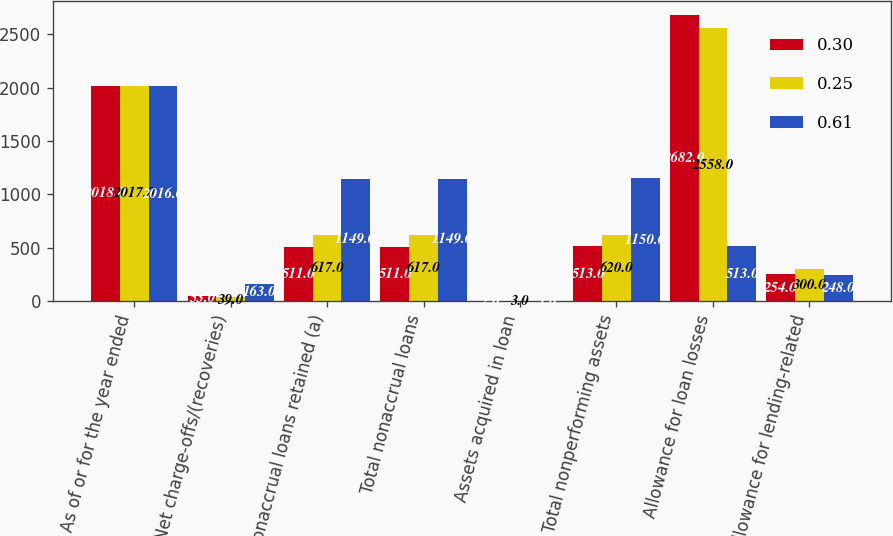Convert chart to OTSL. <chart><loc_0><loc_0><loc_500><loc_500><stacked_bar_chart><ecel><fcel>As of or for the year ended<fcel>Net charge-offs/(recoveries)<fcel>Nonaccrual loans retained (a)<fcel>Total nonaccrual loans<fcel>Assets acquired in loan<fcel>Total nonperforming assets<fcel>Allowance for loan losses<fcel>Allowance for lending-related<nl><fcel>0.3<fcel>2018<fcel>53<fcel>511<fcel>511<fcel>2<fcel>513<fcel>2682<fcel>254<nl><fcel>0.25<fcel>2017<fcel>39<fcel>617<fcel>617<fcel>3<fcel>620<fcel>2558<fcel>300<nl><fcel>0.61<fcel>2016<fcel>163<fcel>1149<fcel>1149<fcel>1<fcel>1150<fcel>513<fcel>248<nl></chart> 